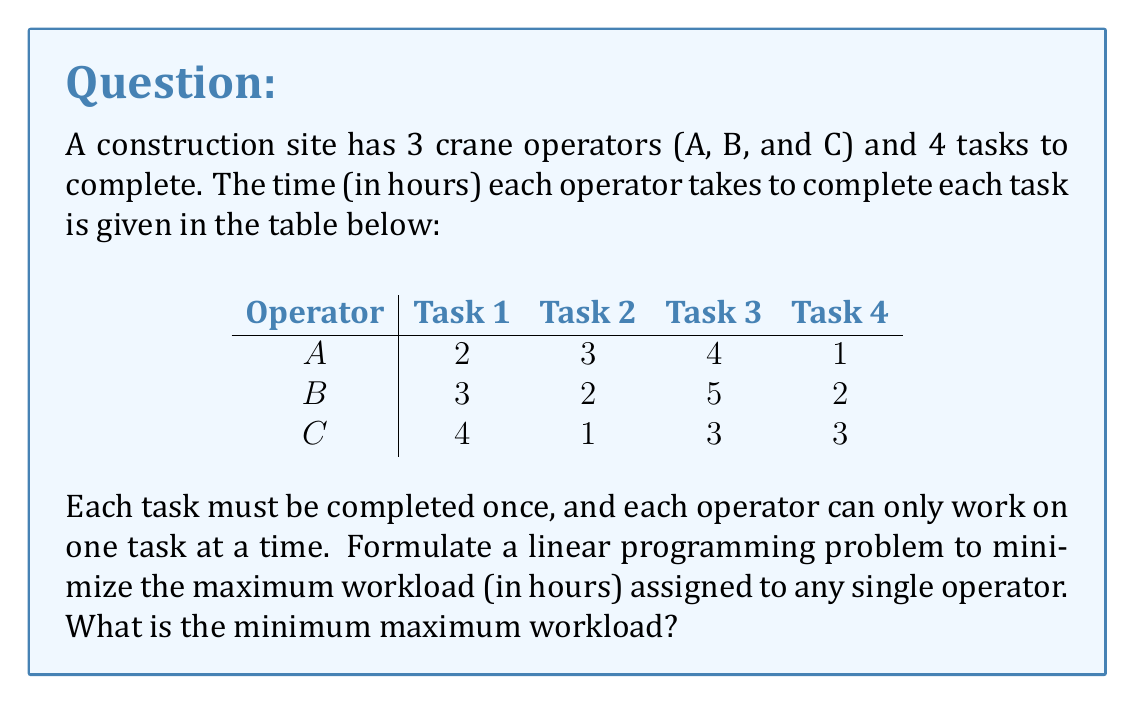Can you solve this math problem? To solve this problem, we'll use linear programming:

1) Define variables:
   Let $x_{ij}$ be a binary variable where $i$ represents the operator (A=1, B=2, C=3) and $j$ represents the task (1-4).
   $x_{ij} = 1$ if operator $i$ is assigned to task $j$, and 0 otherwise.

2) Define the objective function:
   Let $M$ be the maximum workload for any operator.
   Minimize $M$

3) Constraints:
   a) Each task must be assigned to exactly one operator:
      $\sum_{i=1}^3 x_{ij} = 1$ for $j = 1,2,3,4$

   b) The workload for each operator should not exceed $M$:
      $\sum_{j=1}^4 t_{ij}x_{ij} \leq M$ for $i = 1,2,3$
      where $t_{ij}$ is the time taken by operator $i$ for task $j$

   c) Binary constraint:
      $x_{ij} \in \{0,1\}$ for all $i$ and $j$

4) The complete linear program:

   Minimize $M$
   Subject to:
   $x_{11} + x_{21} + x_{31} = 1$
   $x_{12} + x_{22} + x_{32} = 1$
   $x_{13} + x_{23} + x_{33} = 1$
   $x_{14} + x_{24} + x_{34} = 1$
   $2x_{11} + 3x_{12} + 4x_{13} + x_{14} \leq M$
   $3x_{21} + 2x_{22} + 5x_{23} + 2x_{24} \leq M$
   $4x_{31} + x_{32} + 3x_{33} + 3x_{34} \leq M$
   $x_{ij} \in \{0,1\}$ for all $i$ and $j$

5) Solving this linear program (using a solver) gives the optimal solution:
   $x_{14} = x_{22} = x_{33} = x_{31} = 1$, all other $x_{ij} = 0$
   $M = 4$

This means:
- Operator A is assigned Task 4 (1 hour)
- Operator B is assigned Task 2 (2 hours)
- Operator C is assigned Task 3 and Task 1 (3 + 4 = 7 hours)

The maximum workload is 7 hours, assigned to Operator C.
Answer: 7 hours 